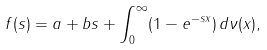Convert formula to latex. <formula><loc_0><loc_0><loc_500><loc_500>f ( s ) = a + b s + \int _ { 0 } ^ { \infty } ( 1 - e ^ { - s x } ) \, d \nu ( x ) ,</formula> 